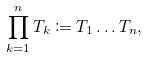Convert formula to latex. <formula><loc_0><loc_0><loc_500><loc_500>\prod _ { k = 1 } ^ { n } T _ { k } \coloneqq T _ { 1 } \dots T _ { n } ,</formula> 